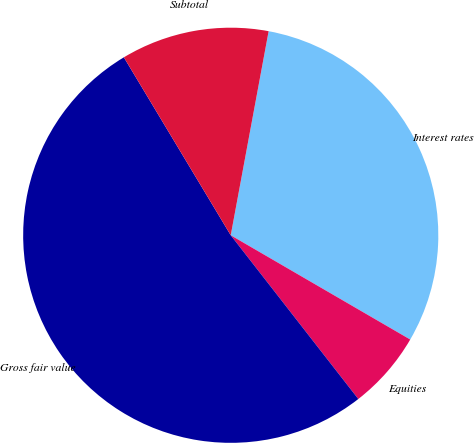Convert chart. <chart><loc_0><loc_0><loc_500><loc_500><pie_chart><fcel>Interest rates<fcel>Equities<fcel>Gross fair value<fcel>Subtotal<nl><fcel>30.45%<fcel>6.09%<fcel>51.92%<fcel>11.53%<nl></chart> 